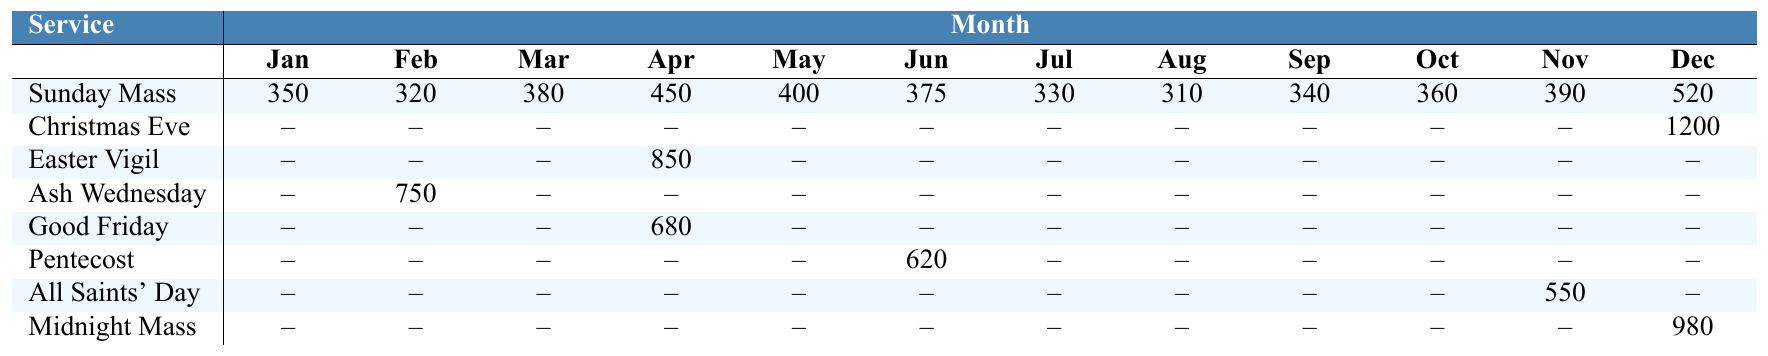What was the attendance for Christmas Eve Service? The table shows that the attendance for Christmas Eve Service in December is 1200.
Answer: 1200 What month had the highest attendance for Sunday Mass? Looking at the row for Sunday Mass, the highest attendance is in December with 520.
Answer: 520 Was there any attendance recorded for Midnight Mass in June? The table indicates that there is no attendance recorded for Midnight Mass in June (it's marked as --).
Answer: No What is the total attendance for Easter Vigil? The only attendance recorded for Easter Vigil is 850 in April. The total is simply 850.
Answer: 850 Which service had the lowest attendance recorded and in which month? Looking across all services, Sunday Mass in August had the lowest attendance of 310.
Answer: Sunday Mass, August, 310 How many services had an attendance of more than 500? From the table, only Christmas Eve Service (1200) and Midnight Mass (980) had attendance over 500. In total, that’s 2 services.
Answer: 2 What is the average attendance for the month of May across all services? For May, the attendances are 400 (Sunday Mass), 0 (Christmas Eve), 0 (Easter Vigil), 0 (Ash Wednesday), 0 (Good Friday), 0 (Pentecost), 0 (All Saints' Day), and 0 (Midnight Mass). The average is 400/8 = 50.
Answer: 50 Did any service have attendance on Ash Wednesday, and if so, what was it? Yes, the table shows that there was an attendance of 750 for Ash Wednesday in February.
Answer: 750 What is the difference in attendance between Good Friday and Ash Wednesday? Good Friday had an attendance of 680 in April, and Ash Wednesday had 750 in February. The difference is 750 - 680 = 70.
Answer: 70 How many months had no attendance recorded for Easter Vigil? The attendance for Easter Vigil was only recorded in April (850). Thus, the number of months with no attendance recorded is 11 (January to March, May to December).
Answer: 11 If we sum the attendances of Sunday Mass for all months, what do we get? Adding the Sunday Mass attendances from January (350) to December (520) gives: 350 + 320 + 380 + 450 + 400 + 375 + 330 + 310 + 340 + 360 + 390 + 520 = 4,600.
Answer: 4600 